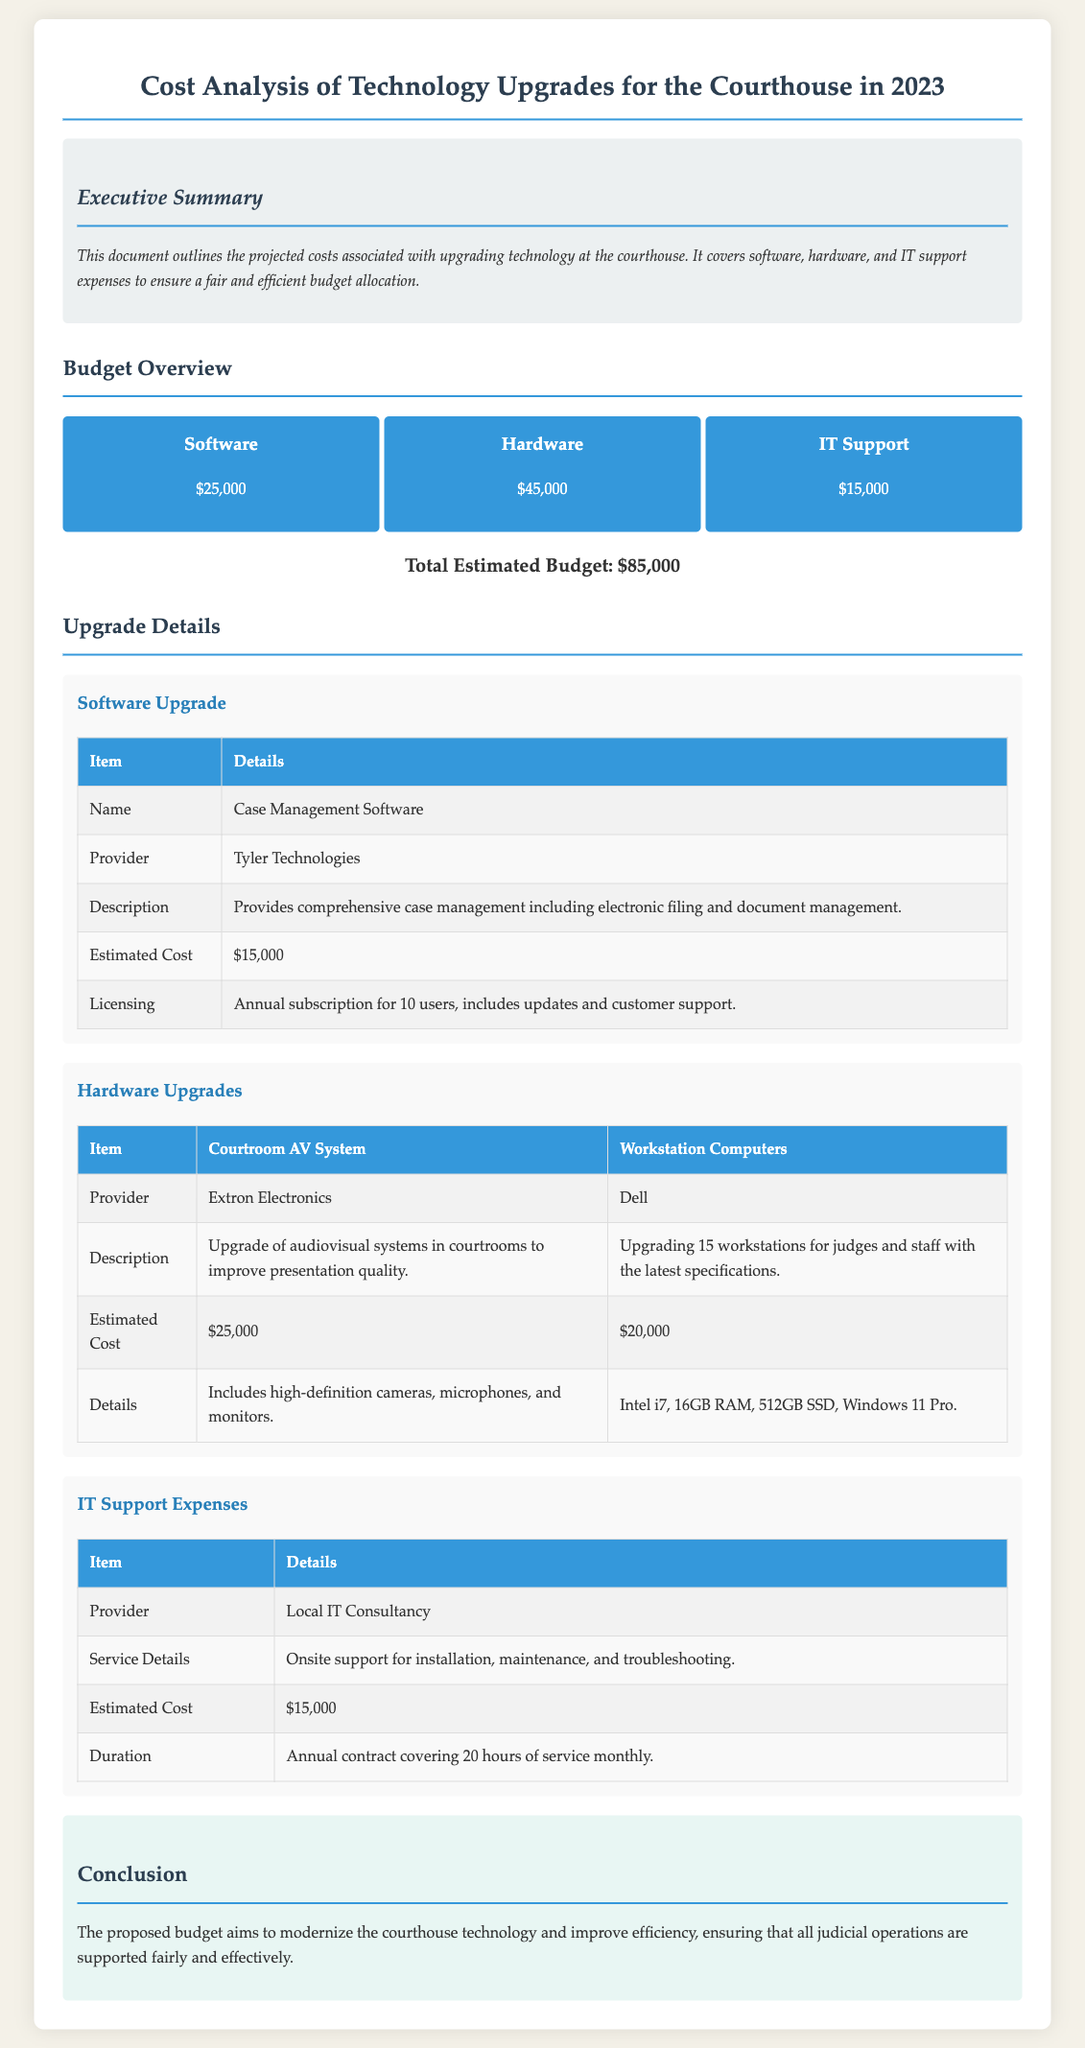What is the total estimated budget? The total estimated budget is provided in the document as the sum of all expenses listed: Software, Hardware, and IT Support, which is $85,000.
Answer: $85,000 Who is the provider for the Case Management Software? The document specifies that the provider for the software is Tyler Technologies.
Answer: Tyler Technologies What is the estimated cost for Hardware upgrades? The estimated cost for Hardware upgrades is listed in the Budget Overview section as $45,000.
Answer: $45,000 How many workstations are being upgraded? The document states that 15 workstations for judges and staff are being upgraded as part of the hardware upgrades.
Answer: 15 What is included in the annual IT Support contract? The IT Support contract covers onsite installation, maintenance, and troubleshooting services as described in the document.
Answer: Onsite support for installation, maintenance, and troubleshooting What is the estimated cost of the Courtroom AV System? The estimated cost of the Courtroom AV System is presented in the Hardware Upgrades section as $25,000.
Answer: $25,000 What type of licensing comes with the Case Management Software? The document outlines that the licensing includes an annual subscription for 10 users, which includes updates and customer support.
Answer: Annual subscription for 10 users, includes updates and customer support What is the duration of the IT Support service? The document mentions that the IT Support service duration is an annual contract covering 20 hours of service monthly.
Answer: Annual contract covering 20 hours of service monthly 